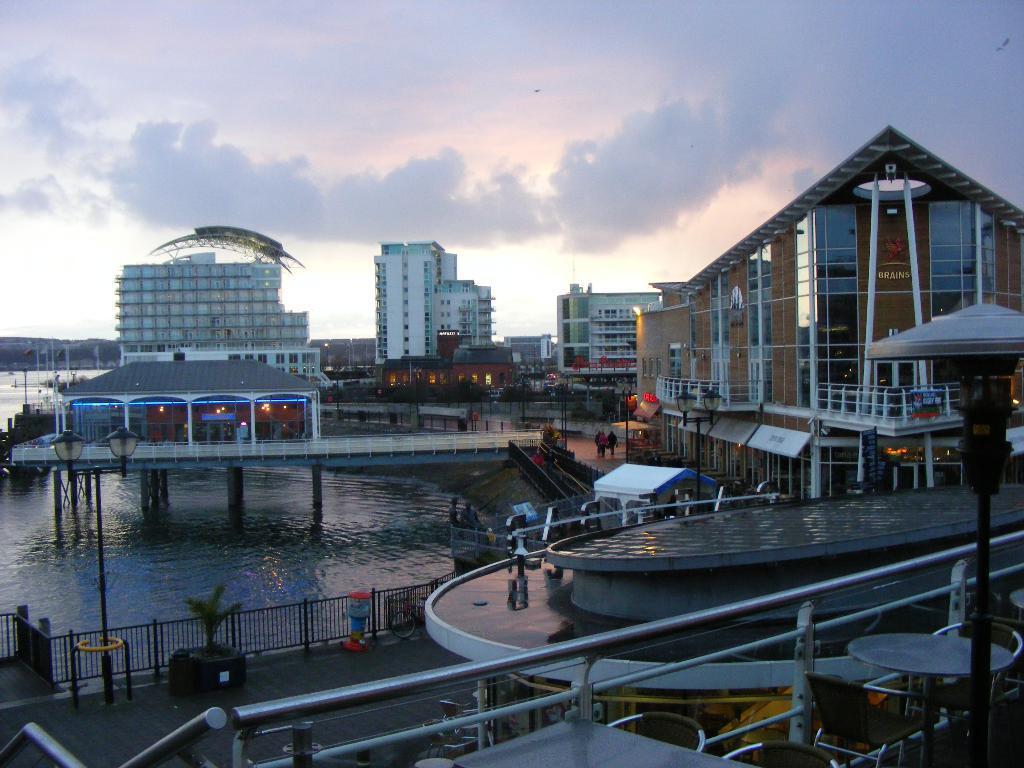How would you summarize this image in a sentence or two? In this picture we can see buildings, there is water in the middle, on the left side we can see a plant and railing, there are some people in the middle, in the background we can see a bridge, at the right bottom there are some chairs and tables, we can see the sky at the top of the picture. 